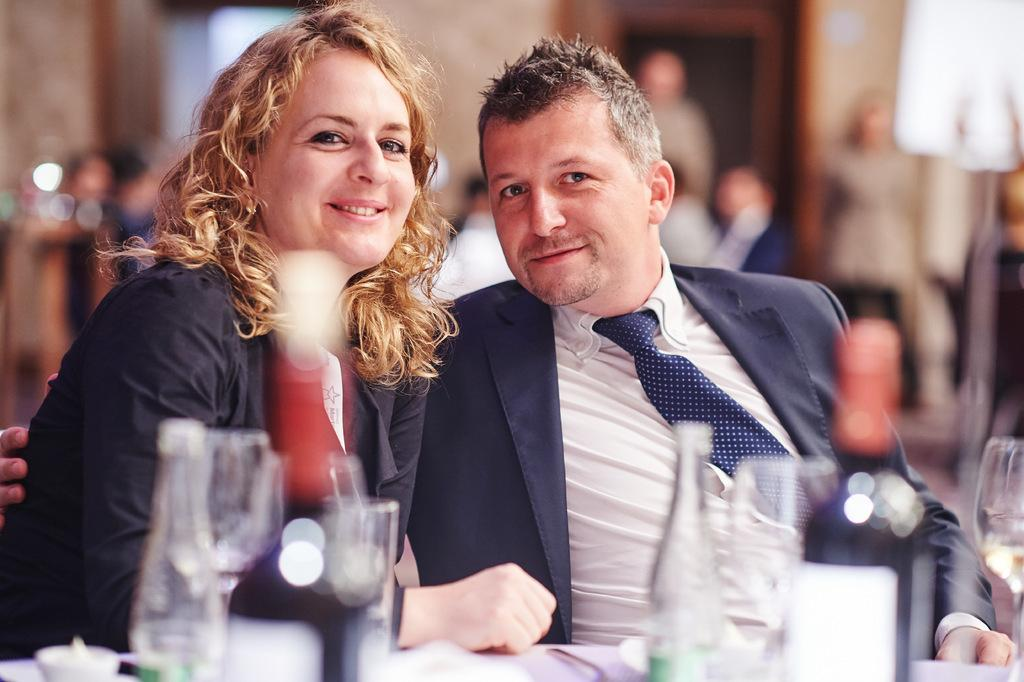What is the main subject of the image? The main subject of the image is a couple sitting. What objects can be seen in the image besides the couple? There are glasses visible in the image. What type of guide is the couple using in the image? There is no guide present in the image; it only features a couple sitting and glasses. 